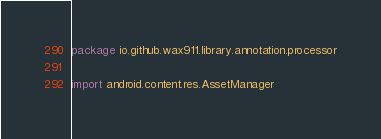Convert code to text. <code><loc_0><loc_0><loc_500><loc_500><_Kotlin_>package io.github.wax911.library.annotation.processor

import android.content.res.AssetManager</code> 